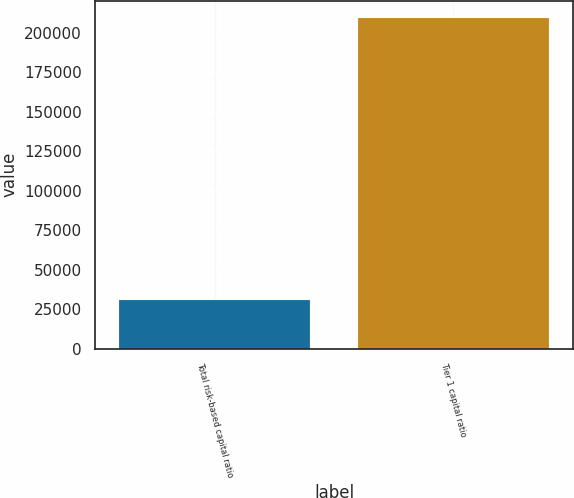<chart> <loc_0><loc_0><loc_500><loc_500><bar_chart><fcel>Total risk-based capital ratio<fcel>Tier 1 capital ratio<nl><fcel>30513<fcel>209758<nl></chart> 